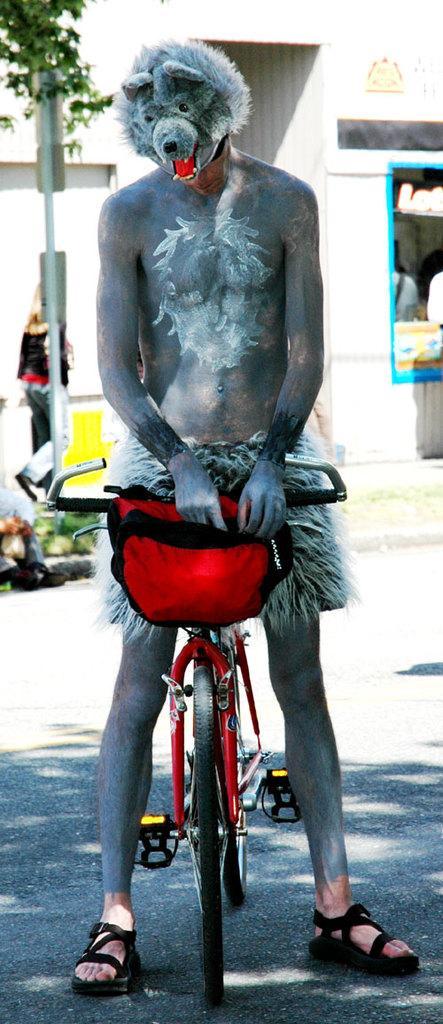Can you describe this image briefly? In this image, In the there is a bicycle which is in red color, There is a man standing on the bicycle he is a wearing a black color mask, In the background there is a pole in white color, There is a wall which is in white color, There is a green color plant. 